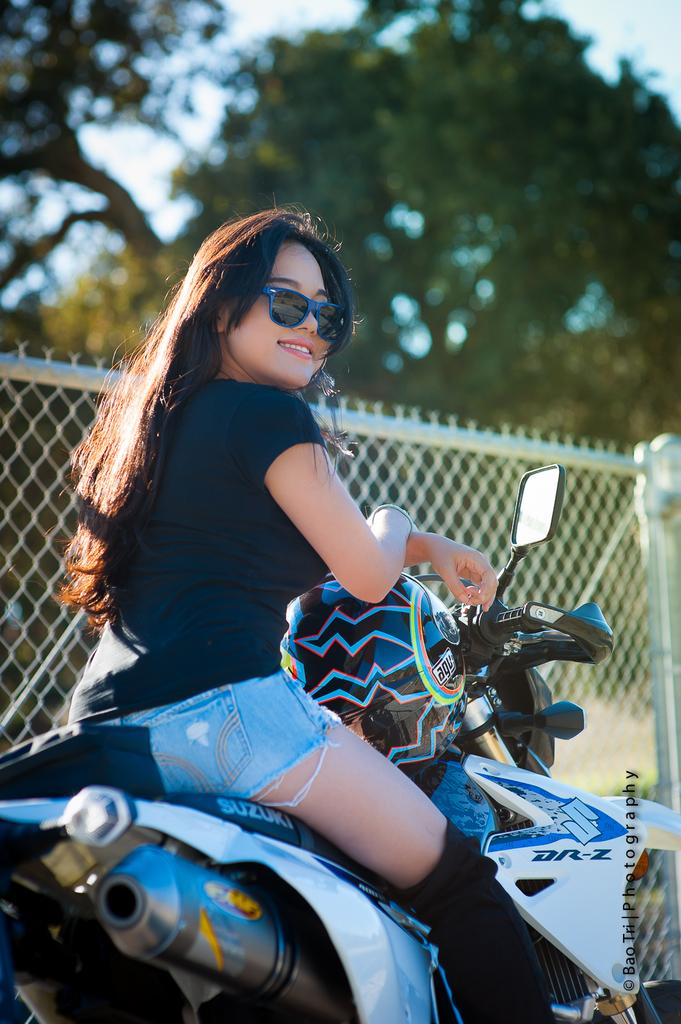Who is the main subject in the image? There is a woman in the image. What is the woman doing in the image? The woman is sitting on a bike. What item is the woman holding in the image? The woman is holding a helmet. What type of structure is near the woman? There is an iron mesh near the woman. What type of natural environment is visible in the image? There are trees in the image. What is the condition of the sky in the image? The sky is clear in the image. What type of sweater is the deer wearing in the image? There is no deer present in the image, and therefore no sweater can be observed. 